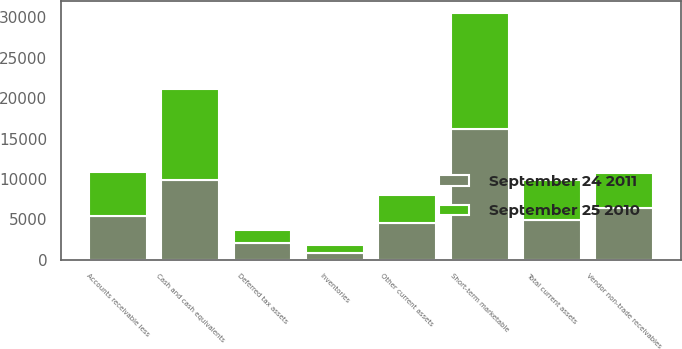Convert chart. <chart><loc_0><loc_0><loc_500><loc_500><stacked_bar_chart><ecel><fcel>Cash and cash equivalents<fcel>Short-term marketable<fcel>Accounts receivable less<fcel>Inventories<fcel>Deferred tax assets<fcel>Vendor non-trade receivables<fcel>Other current assets<fcel>Total current assets<nl><fcel>September 24 2011<fcel>9815<fcel>16137<fcel>5369<fcel>776<fcel>2014<fcel>6348<fcel>4529<fcel>4949<nl><fcel>September 25 2010<fcel>11261<fcel>14359<fcel>5510<fcel>1051<fcel>1636<fcel>4414<fcel>3447<fcel>4949<nl></chart> 